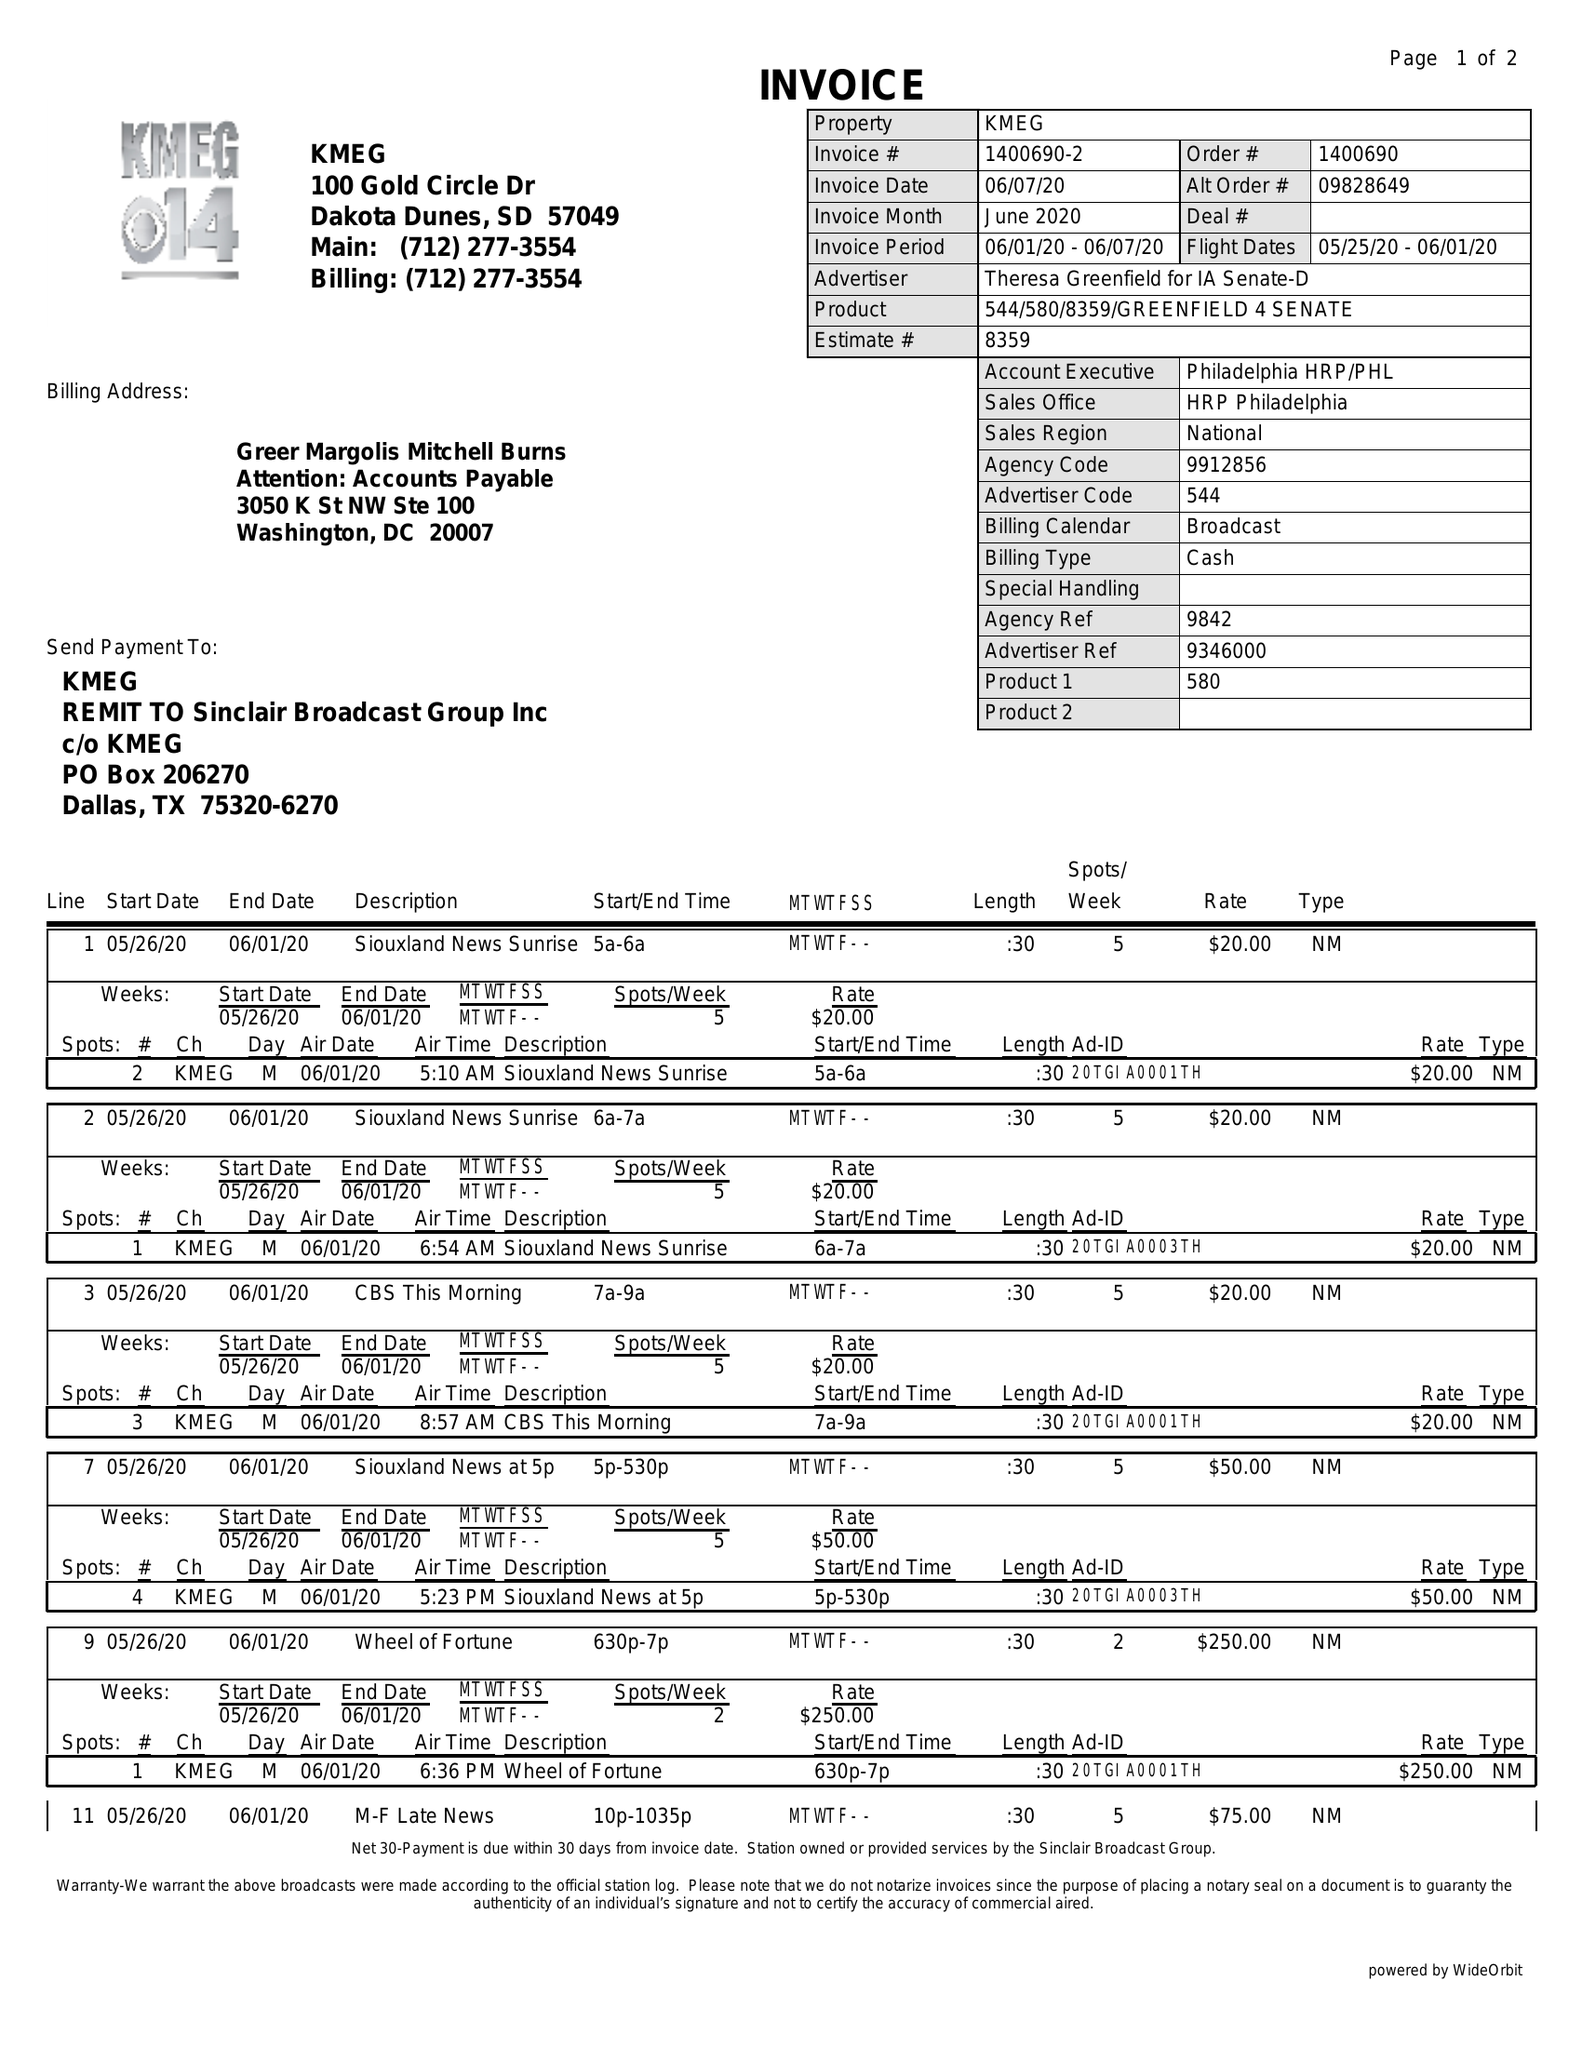What is the value for the gross_amount?
Answer the question using a single word or phrase. 450.00 